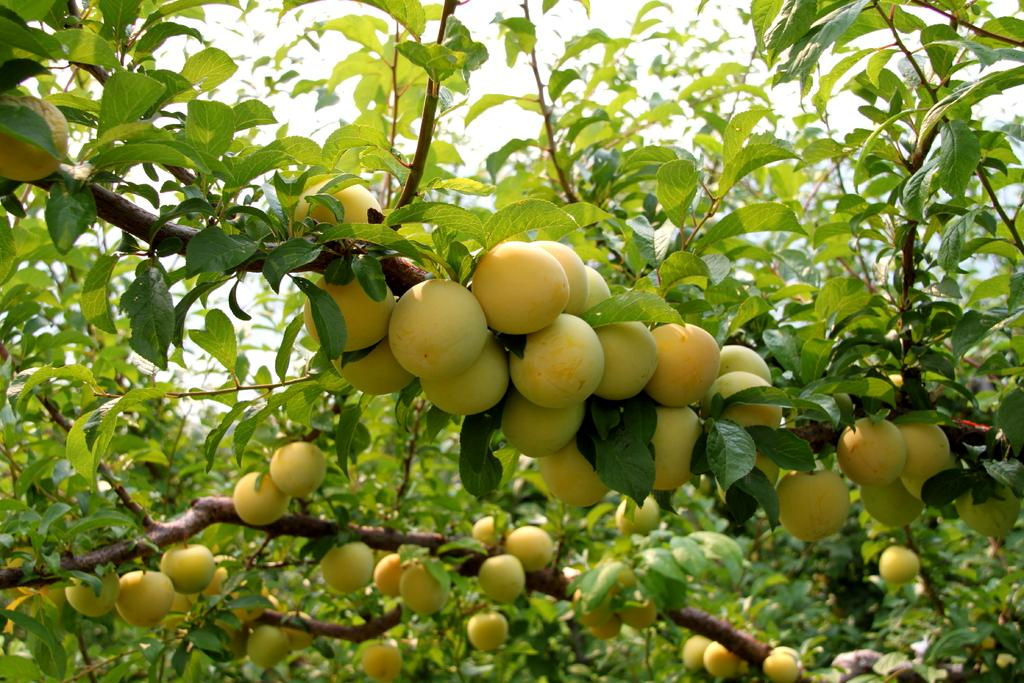What is the main object in the image? There is a tree in the image. What is on the tree? There are fruits on the tree. What can be seen in the background of the image? The sky is visible in the background of the image. How many feet are visible on the tree in the image? There are no feet visible on the tree in the image, as trees do not have feet. 